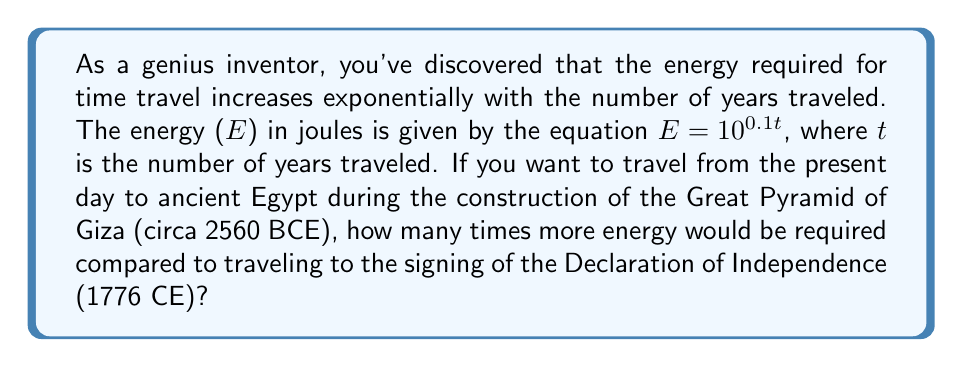Can you solve this math problem? Let's approach this step-by-step:

1) First, we need to calculate the number of years for each trip:
   - To ancient Egypt: 2023 + 2560 = 4583 years
   - To the Declaration of Independence: 2023 - 1776 = 247 years

2) Now, let's calculate the energy required for each trip:
   - For ancient Egypt: 
     $E_1 = 10^{0.1 \times 4583} = 10^{458.3}$ joules

   - For the Declaration of Independence:
     $E_2 = 10^{0.1 \times 247} = 10^{24.7}$ joules

3) To find how many times more energy is required, we divide $E_1$ by $E_2$:

   $\frac{E_1}{E_2} = \frac{10^{458.3}}{10^{24.7}} = 10^{458.3 - 24.7} = 10^{433.6}$

4) Therefore, traveling to ancient Egypt requires $10^{433.6}$ times more energy than traveling to 1776.
Answer: $10^{433.6}$ 